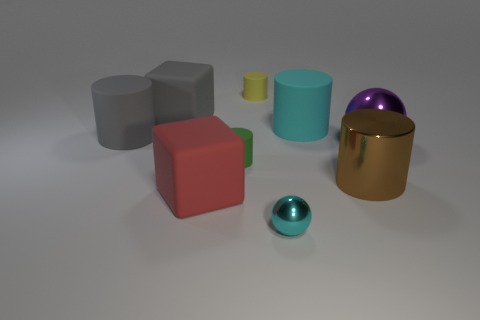Subtract 2 cylinders. How many cylinders are left? 3 Subtract all purple cylinders. Subtract all blue balls. How many cylinders are left? 5 Add 1 large red things. How many objects exist? 10 Subtract all blocks. How many objects are left? 7 Add 4 brown shiny objects. How many brown shiny objects are left? 5 Add 9 large purple cylinders. How many large purple cylinders exist? 9 Subtract 0 brown spheres. How many objects are left? 9 Subtract all big purple spheres. Subtract all cyan spheres. How many objects are left? 7 